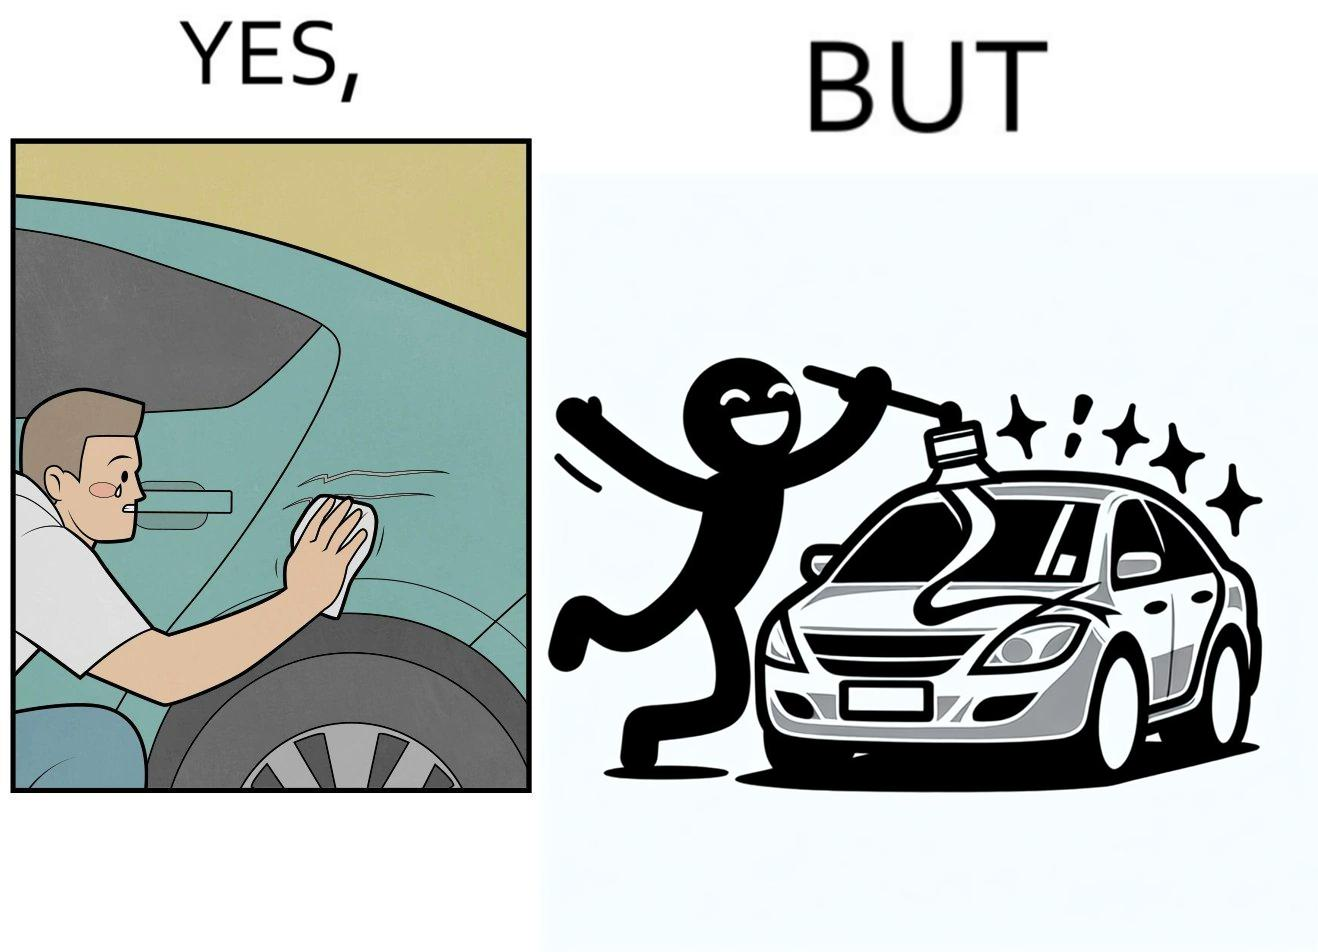Would you classify this image as satirical? Yes, this image is satirical. 